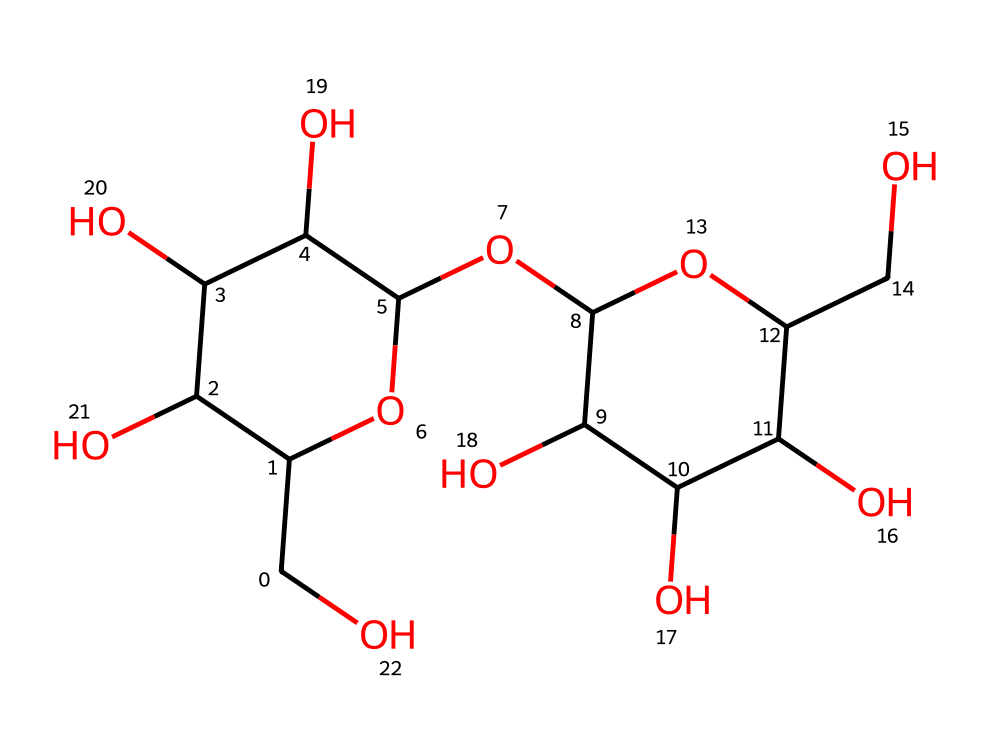what type of chemical is represented by this SMILES? The SMILES notation provided corresponds to the structure of starch, which is a type of polymer made from glucose units. The presence of multiple sugar units (in this case, glucose) linked together in a long chain indicates that it is a polysaccharide, commonly found in various grocery products.
Answer: polysaccharide how many cyclic structures are present in this molecule? By examining the SMILES, we can see that there are two distinct ring structures indicated by the 'C1' and 'C2' in the notation. Each of these points creates a cyclic arrangement for the glucose units in the starch polymer, highlighting the presence of two cyclic structures.
Answer: two what is the primary building block of this polymer? The SMILES structure shows that this polymer is composed of repeated glucose units as the primary building blocks. Each repeating unit in the starch polymer is specifically glucose, which is the basic monomer that forms starch.
Answer: glucose how many hydroxyl groups are present in this molecule? By counting the 'O' atoms that are bonded to carbon atoms, specifically those that appear at the ends of the chain and branching points, we find that there are eight hydroxyl groups – evidenced by their locations and representation in the structure.
Answer: eight what is the general property of this polymer related to water? The numerous hydroxyl groups present in this starch molecule contribute to its hydrophilic nature, meaning that starch has a tendency to absorb water and swell in its presence. This property facilitates its use as a thickening agent in cooking.
Answer: hydrophilic how does the molecular arrangement influence the digestibility of this starch? The structure's extensive branching and the arrangement of glucose units can influence how quickly enzymes can access and break down the chains into glucose. More branching typically means faster digestion, while linear structures allow for slower release. This molecular arrangement significantly affects how quickly the starch is digested and used by the body.
Answer: influences digestibility 